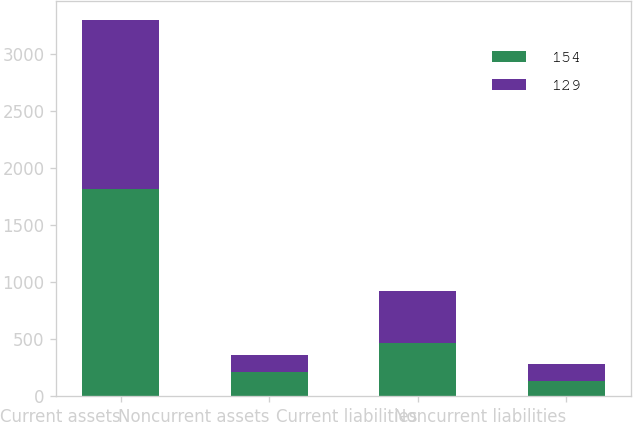Convert chart to OTSL. <chart><loc_0><loc_0><loc_500><loc_500><stacked_bar_chart><ecel><fcel>Current assets<fcel>Noncurrent assets<fcel>Current liabilities<fcel>Noncurrent liabilities<nl><fcel>154<fcel>1819<fcel>208<fcel>469<fcel>129<nl><fcel>129<fcel>1486<fcel>149<fcel>456<fcel>154<nl></chart> 